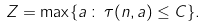<formula> <loc_0><loc_0><loc_500><loc_500>Z = \max \{ a \, \colon \, \tau ( n , a ) \leq C \} .</formula> 